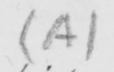Can you tell me what this handwritten text says? ( A ) 